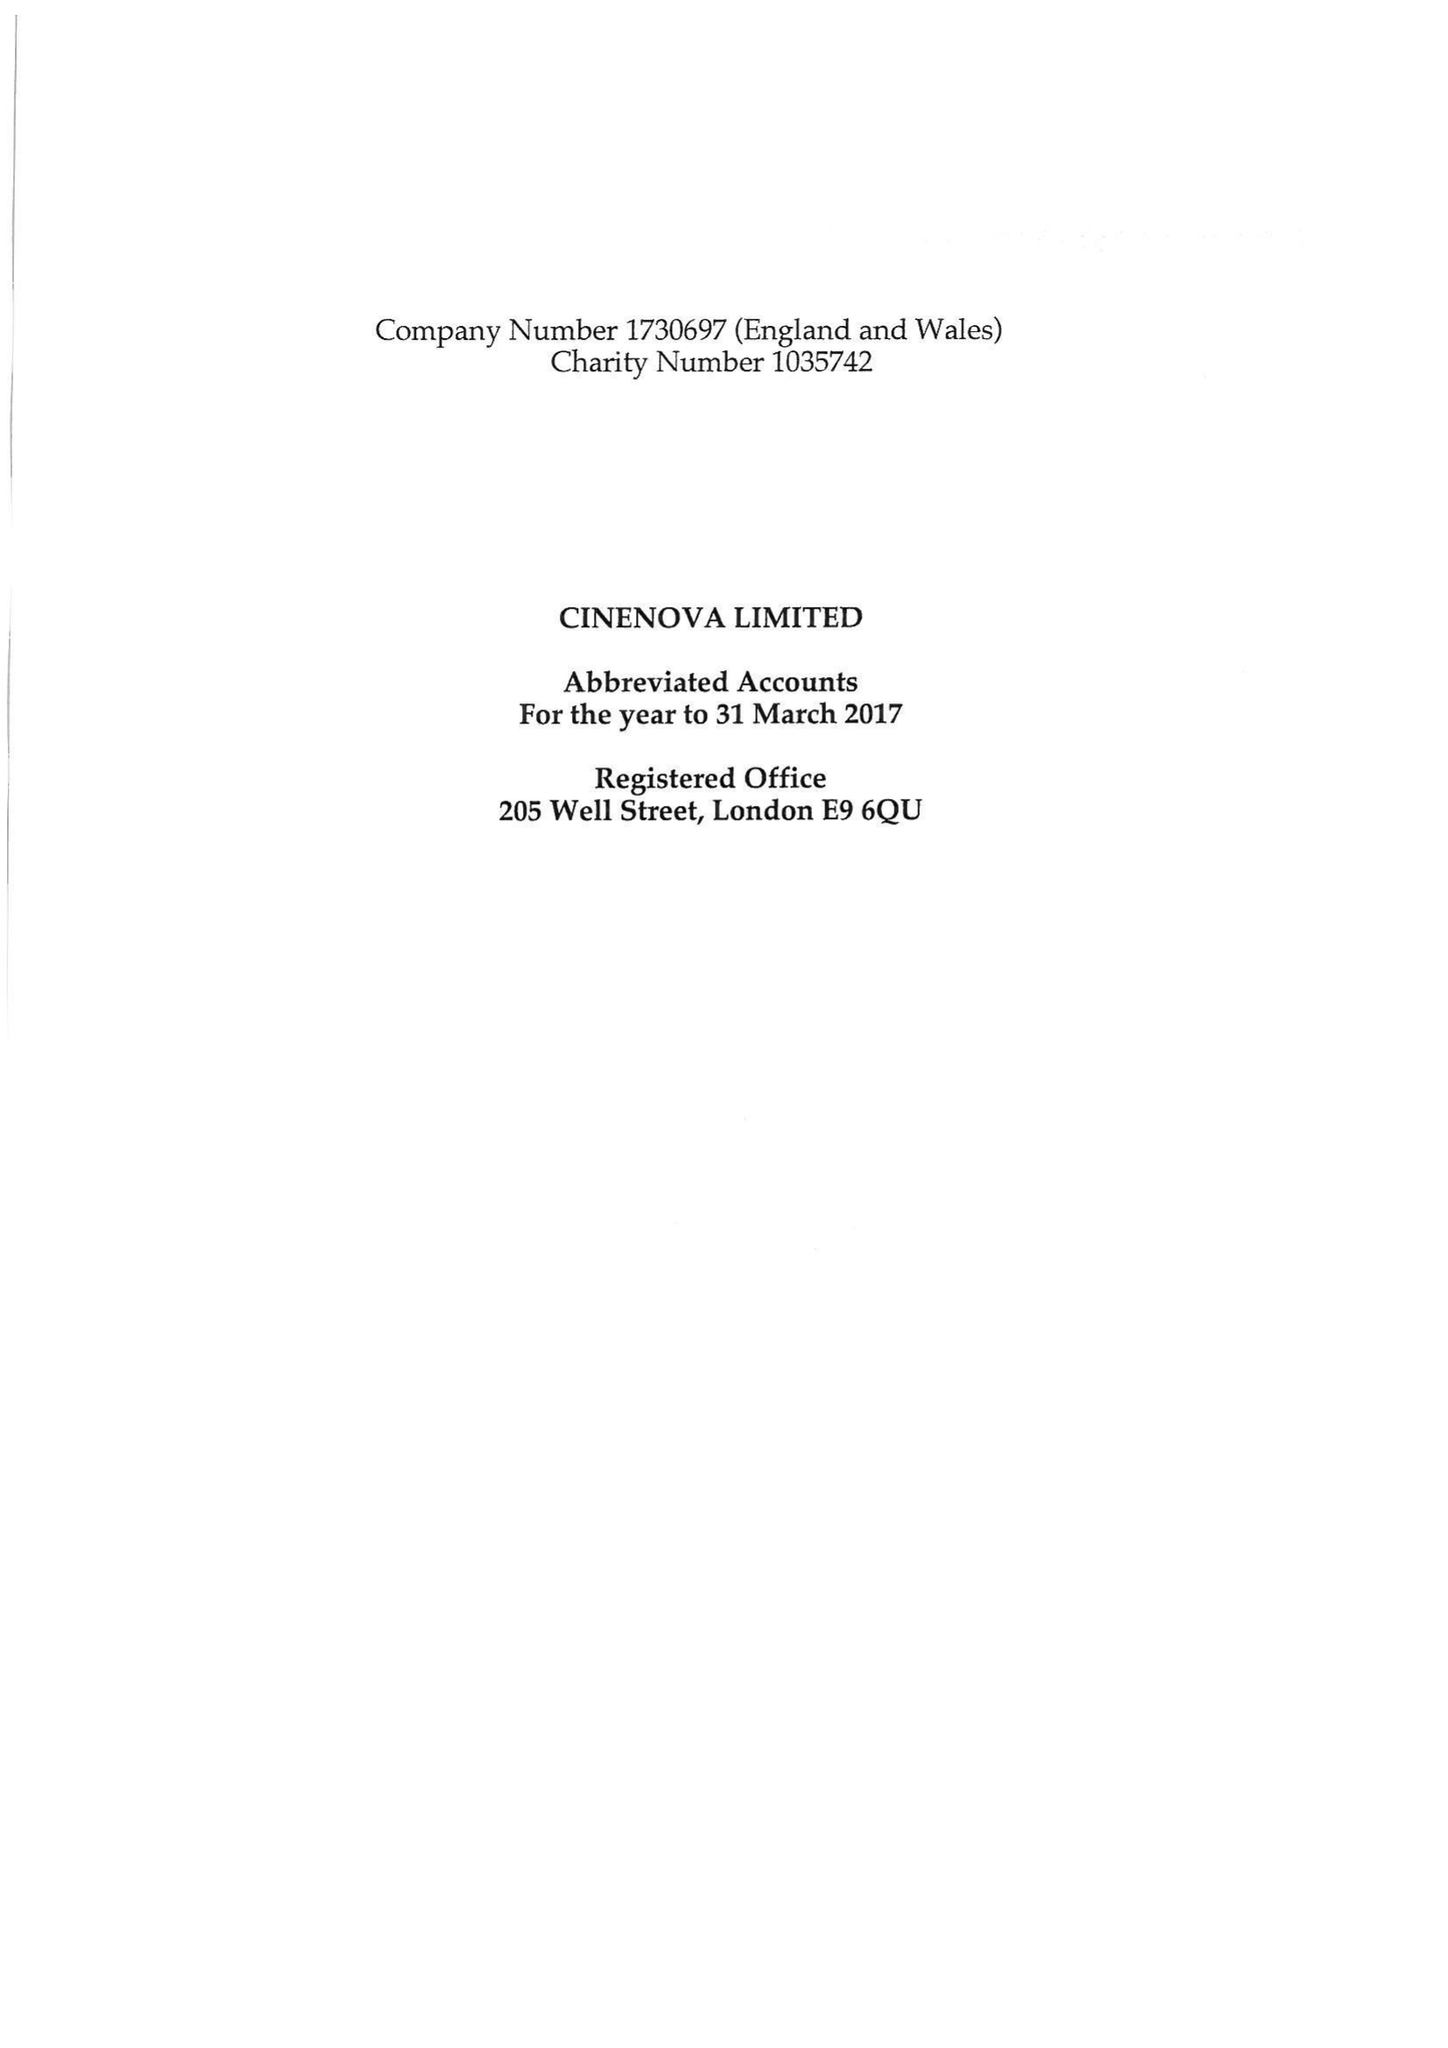What is the value for the charity_name?
Answer the question using a single word or phrase. Cinenova Ltd. 